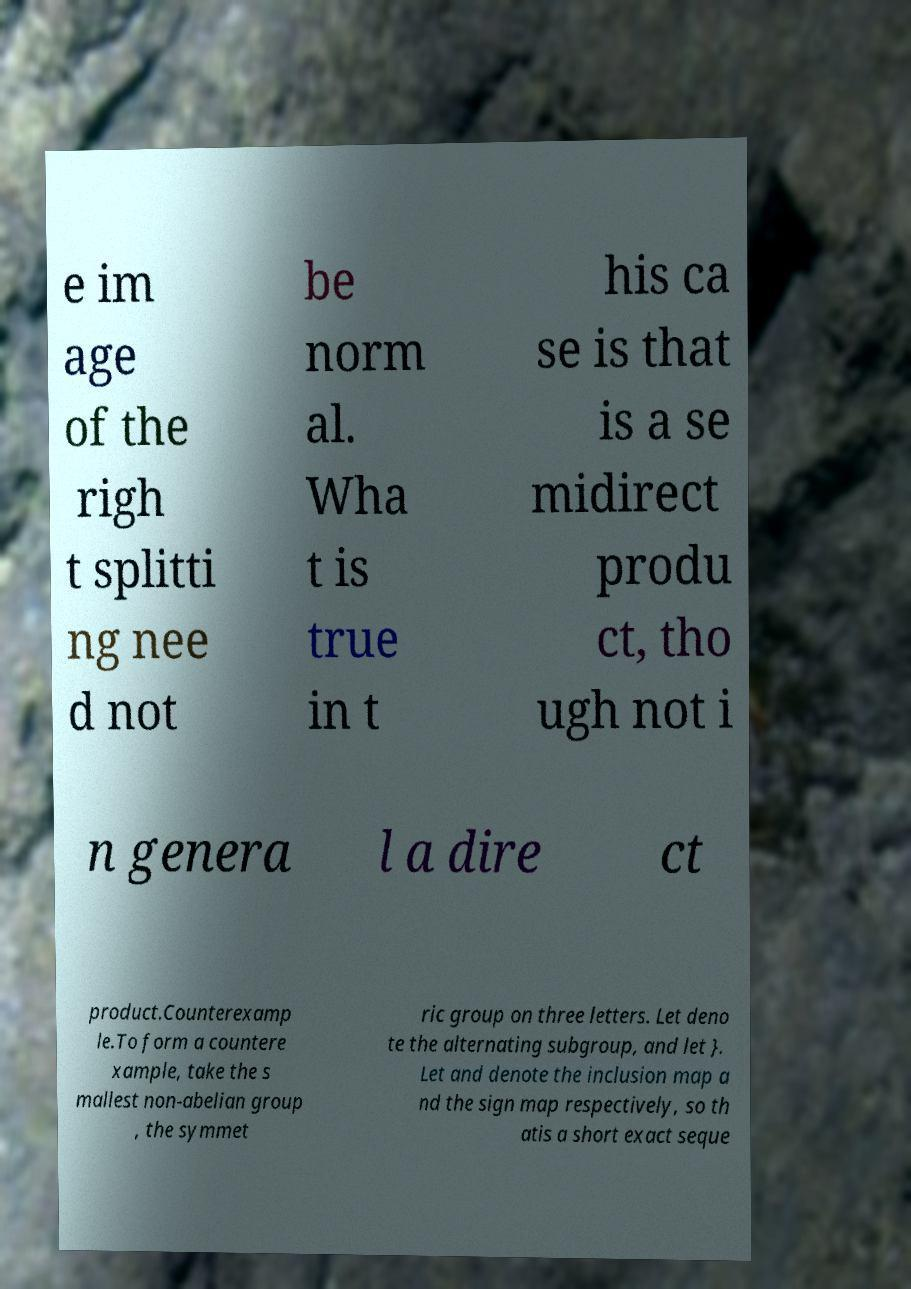For documentation purposes, I need the text within this image transcribed. Could you provide that? e im age of the righ t splitti ng nee d not be norm al. Wha t is true in t his ca se is that is a se midirect produ ct, tho ugh not i n genera l a dire ct product.Counterexamp le.To form a countere xample, take the s mallest non-abelian group , the symmet ric group on three letters. Let deno te the alternating subgroup, and let }. Let and denote the inclusion map a nd the sign map respectively, so th atis a short exact seque 